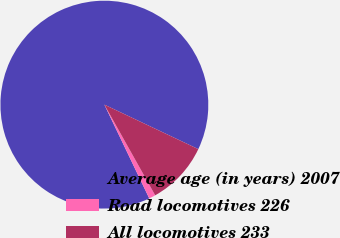Convert chart to OTSL. <chart><loc_0><loc_0><loc_500><loc_500><pie_chart><fcel>Average age (in years) 2007<fcel>Road locomotives 226<fcel>All locomotives 233<nl><fcel>89.15%<fcel>1.02%<fcel>9.83%<nl></chart> 